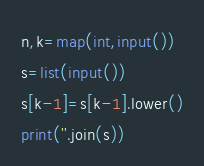<code> <loc_0><loc_0><loc_500><loc_500><_Python_>n,k=map(int,input())
s=list(input())
s[k-1]=s[k-1].lower()
print(''.join(s))
</code> 